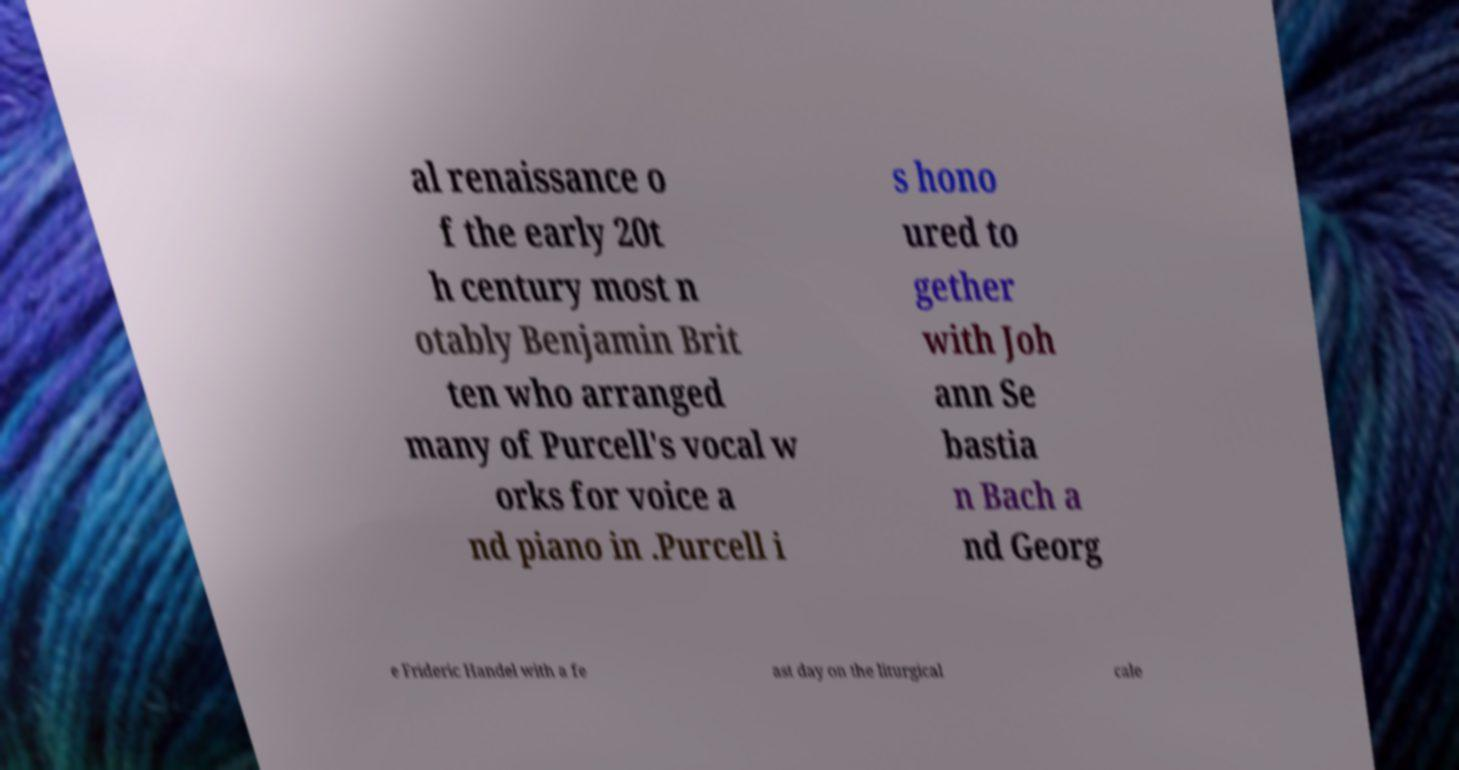Could you assist in decoding the text presented in this image and type it out clearly? al renaissance o f the early 20t h century most n otably Benjamin Brit ten who arranged many of Purcell's vocal w orks for voice a nd piano in .Purcell i s hono ured to gether with Joh ann Se bastia n Bach a nd Georg e Frideric Handel with a fe ast day on the liturgical cale 